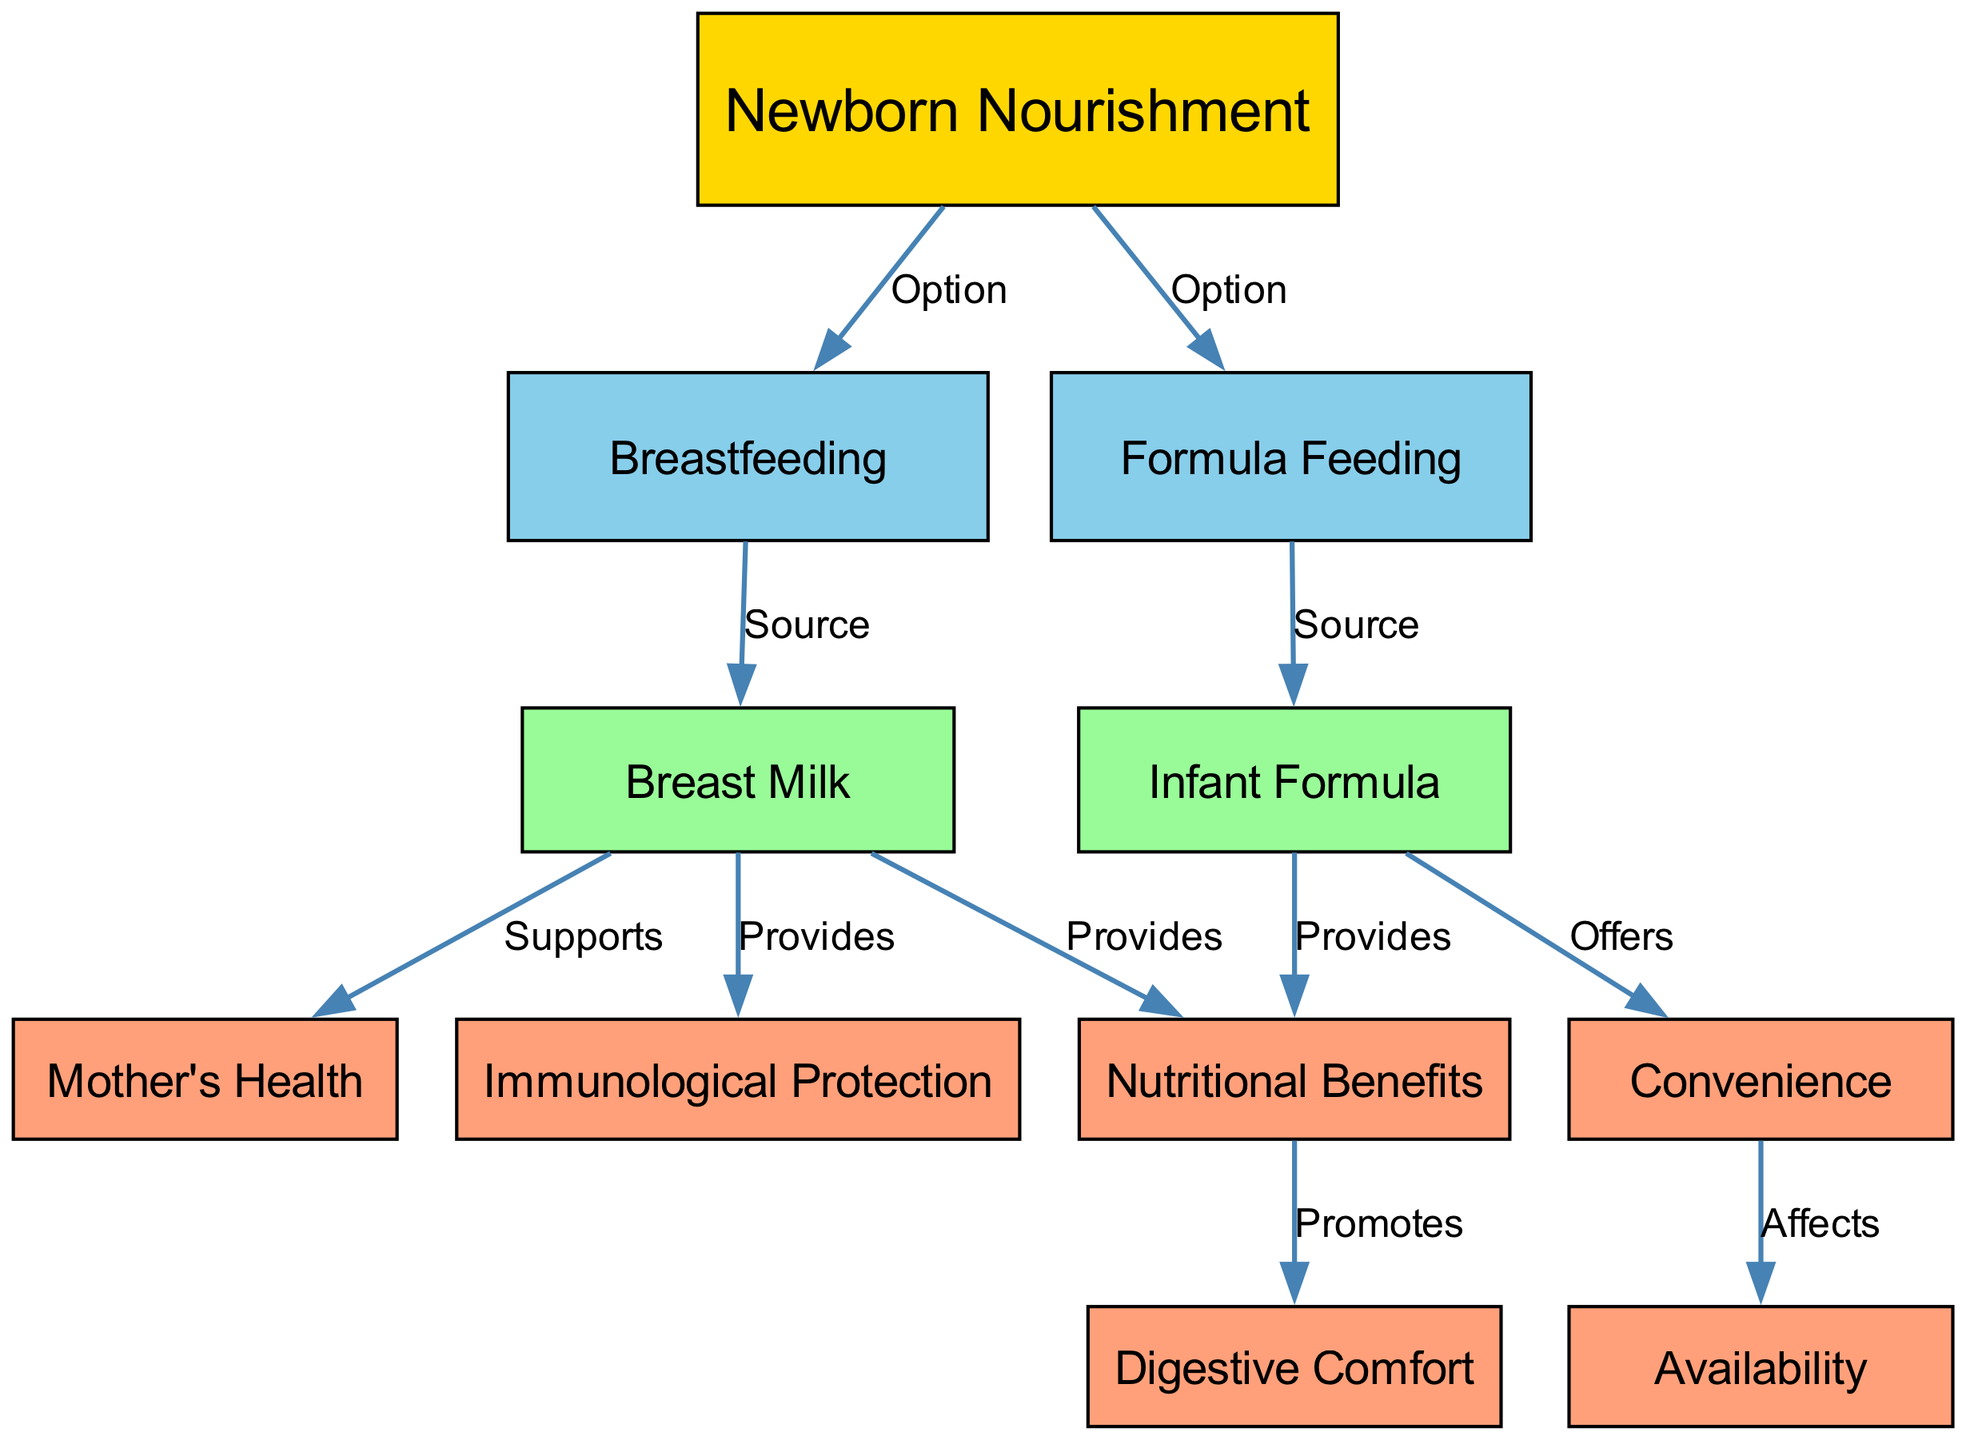What are the two options for newborn nourishment? In the diagram, there are two main options for nourishing a newborn, indicated by the first node ("Newborn Nourishment") leading to "Breastfeeding" and "Formula Feeding".
Answer: Breastfeeding and Formula Feeding How many nodes are in the diagram? By counting all the individual nodes listed in the data provided, we find that there are a total of 11 nodes.
Answer: 11 Which source does breastfeeding provide? The diagram shows that breastfeeding leads to the node labeled "Breast Milk", indicating that breast milk is the source of breastfeeding.
Answer: Breast Milk What nutritional benefits does breast milk provide? According to the diagram, breast milk provides both "Nutritional Benefits" and "Immunological Protection", connecting directly to those nodes.
Answer: Nutritional Benefits and Immunological Protection Which node supports the mother's health? The diagram indicates that breast milk supports the "Mother's Health", as there is a direct connection from the "Breast Milk" node to the "Mother's Health" node.
Answer: Mother's Health What does formula feeding offer in terms of convenience? The diagram illustrates that formula feeding leads to the "Convenience" node, which suggests that it offers certain conveniences for caregivers.
Answer: Convenience Which node promotes digestive comfort? The diagram indicates that the "Nutritional Benefits" node promotes "Digestive Comfort", creating a relationship between these two concepts.
Answer: Digestive Comfort How many edges are present between nodes in the diagram? By tallying the connecting edges in the provided data, we can see there are a total of 10 edges that link the nodes in the diagram.
Answer: 10 What type of protection does breast milk provide? The diagram shows that breast milk provides "Immunological Protection", as it leads directly to that node.
Answer: Immunological Protection What affects the availability of formula feeding? The diagram indicates that "Convenience" affects the "Availability" of formula feeding, illustrating the relationship between these two concepts.
Answer: Availability 